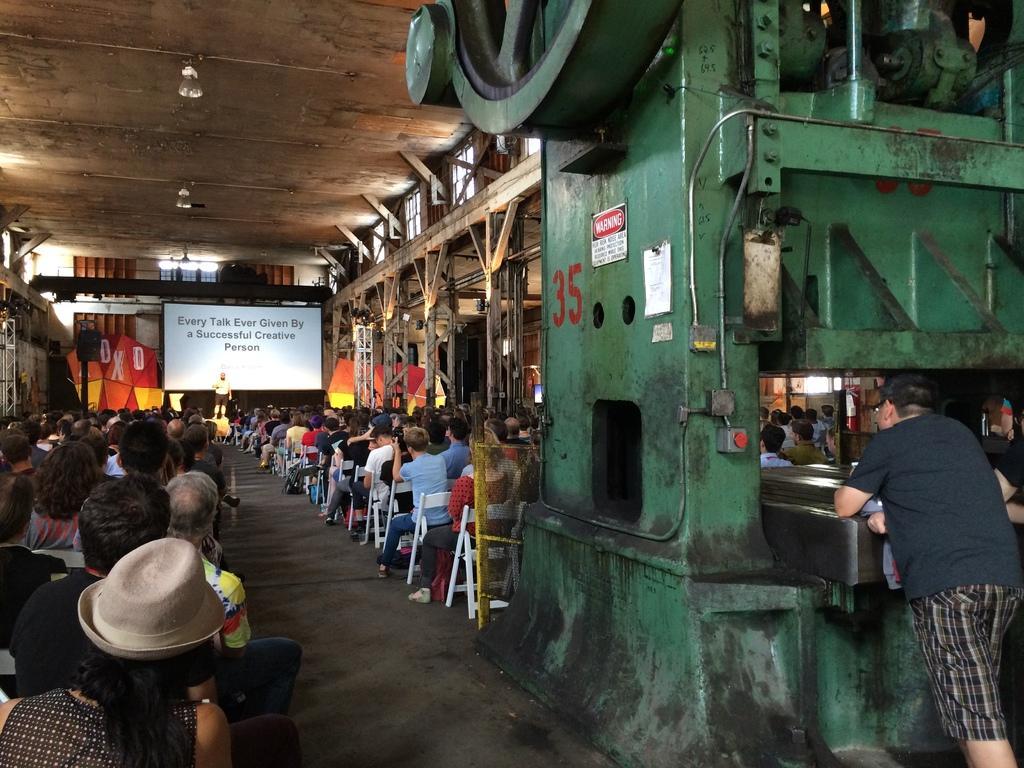In one or two sentences, can you explain what this image depicts? Here we can see a screen, banner, machine, posters, and group of people sitting on the chairs. There is a person standing on the floor. Here we can see lights and poles. 